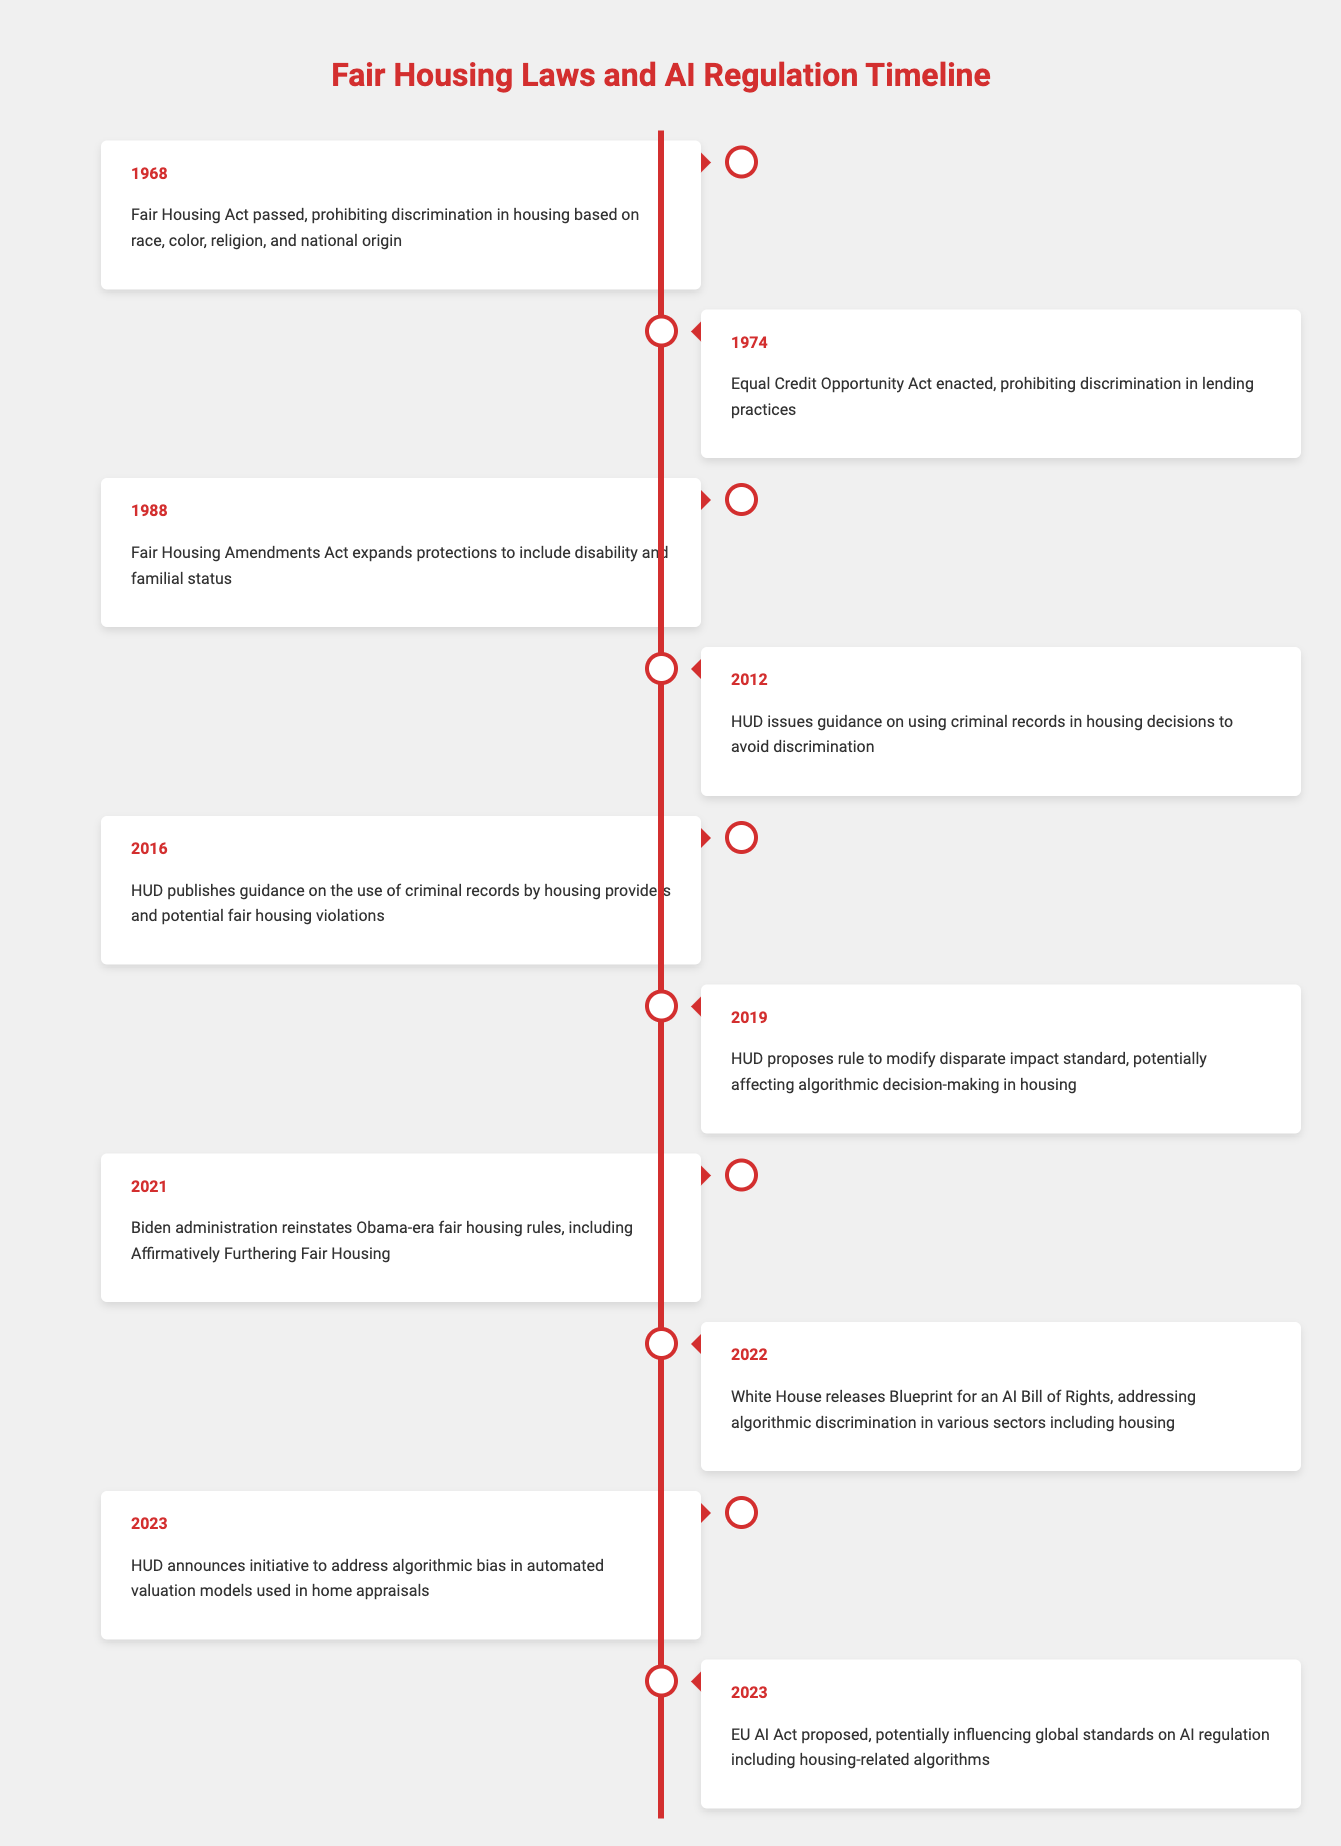What year was the Fair Housing Act passed? The Fair Housing Act was passed in 1968, as indicated in the first entry of the table.
Answer: 1968 What event occurred in 2021 related to fair housing? The Biden administration reinstated Obama-era fair housing rules, including Affirmatively Furthering Fair Housing, as noted in the entry for 2021.
Answer: The reinstatement of Obama-era fair housing rules In what year did HUD propose a rule to modify the disparate impact standard? HUD proposed the rule to modify the disparate impact standard in 2019, as listed in that year's entry.
Answer: 2019 Did the Fair Housing Amendments Act of 1988 expand protections to include disability? Yes, the Fair Housing Amendments Act of 1988 expanded protections to include disability and familial status, as stated in the entry for that year.
Answer: Yes What is the difference in years between the passing of the Fair Housing Act and the Equal Credit Opportunity Act? The Fair Housing Act was passed in 1968 and the Equal Credit Opportunity Act in 1974. The difference is 1974 - 1968 = 6 years.
Answer: 6 years What guidance did HUD issue in 2012 regarding criminal records? HUD issued guidance on using criminal records in housing decisions to avoid discrimination in 2012, as indicated in that year's entry.
Answer: Guidance on using criminal records Which initiative did HUD announce in 2023 concerning algorithmic bias? In 2023, HUD announced an initiative to address algorithmic bias in automated valuation models used in home appraisals, as detailed in the entry for that year.
Answer: Initiative to address algorithmic bias in home appraisals What is the significance of the Blueprint for an AI Bill of Rights released in 2022? The Blueprint for an AI Bill of Rights released in 2022 addresses algorithmic discrimination across various sectors, including housing; this reflects growing attention to the impacts of algorithms on fair housing practices.
Answer: Addresses algorithmic discrimination in housing In which year did HUD publish guidance on potential fair housing violations related to criminal records? HUD published guidance on the use of criminal records by housing providers and potential fair housing violations in 2016, as indicated in that entry.
Answer: 2016 What does the proposed EU AI Act in 2023 potentially influence? The proposed EU AI Act in 2023 potentially influences global standards on AI regulation, including regulations related to housing-related algorithms, reflecting a move towards more consistent global ethics in AI.
Answer: It potentially influences global AI standards 